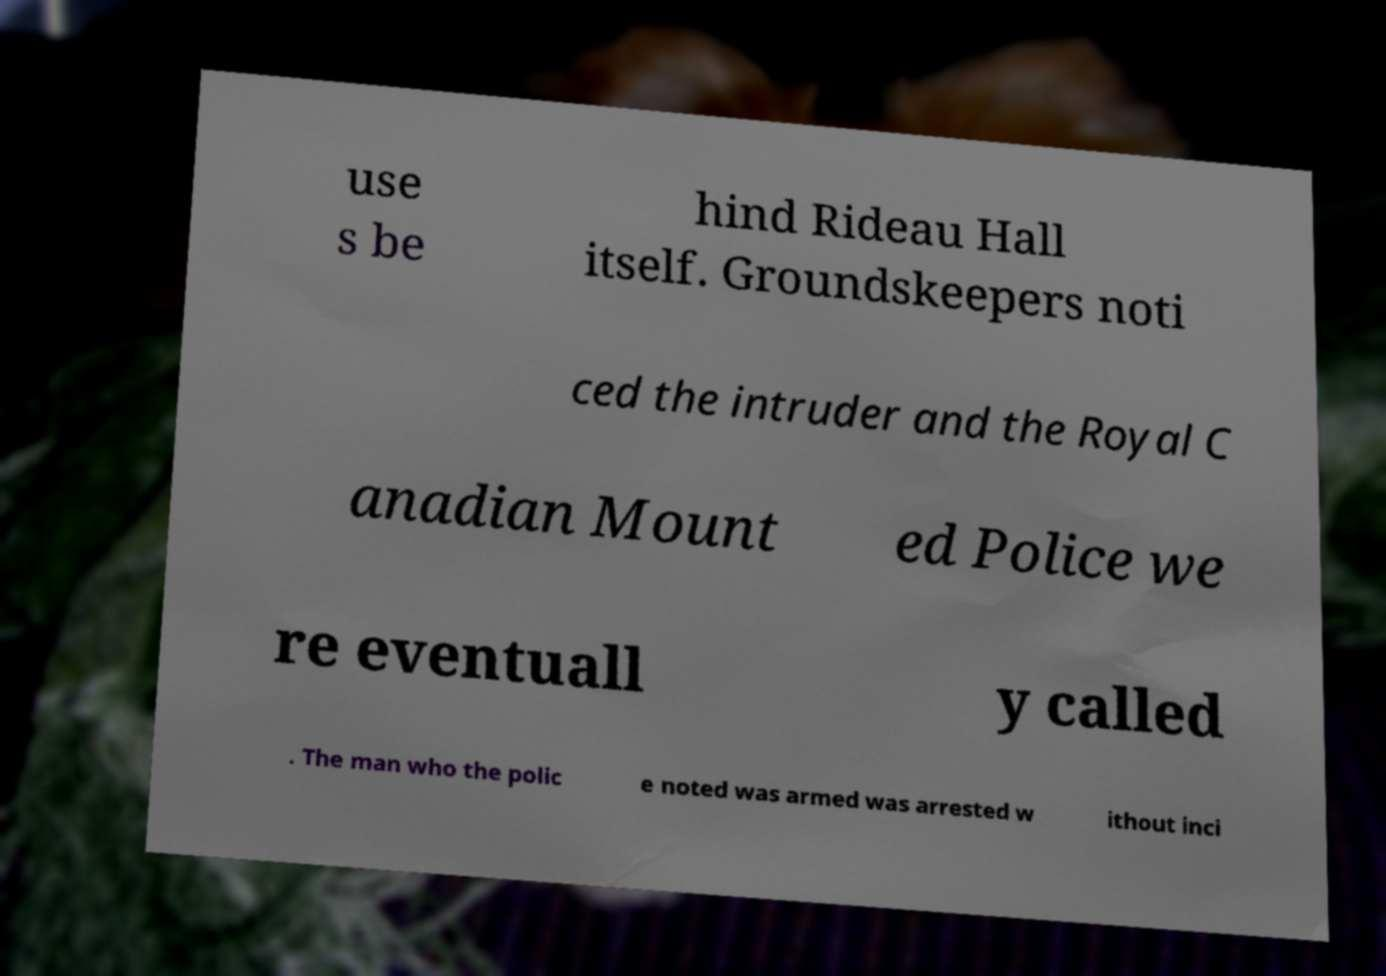Could you assist in decoding the text presented in this image and type it out clearly? use s be hind Rideau Hall itself. Groundskeepers noti ced the intruder and the Royal C anadian Mount ed Police we re eventuall y called . The man who the polic e noted was armed was arrested w ithout inci 